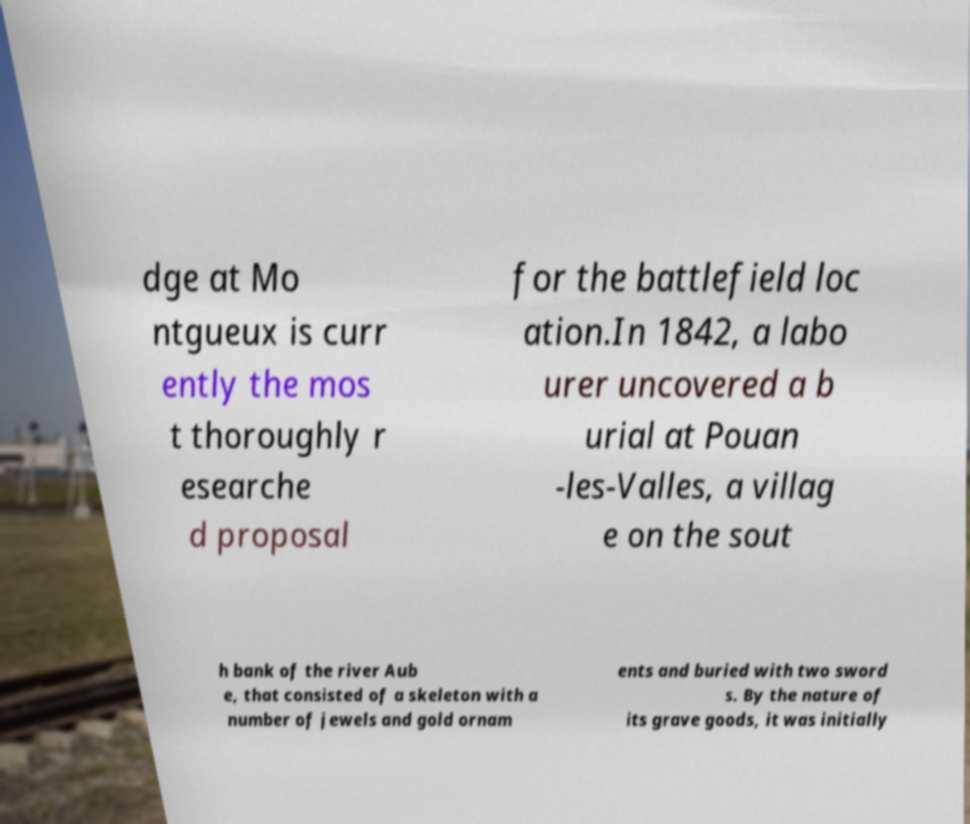Can you accurately transcribe the text from the provided image for me? dge at Mo ntgueux is curr ently the mos t thoroughly r esearche d proposal for the battlefield loc ation.In 1842, a labo urer uncovered a b urial at Pouan -les-Valles, a villag e on the sout h bank of the river Aub e, that consisted of a skeleton with a number of jewels and gold ornam ents and buried with two sword s. By the nature of its grave goods, it was initially 